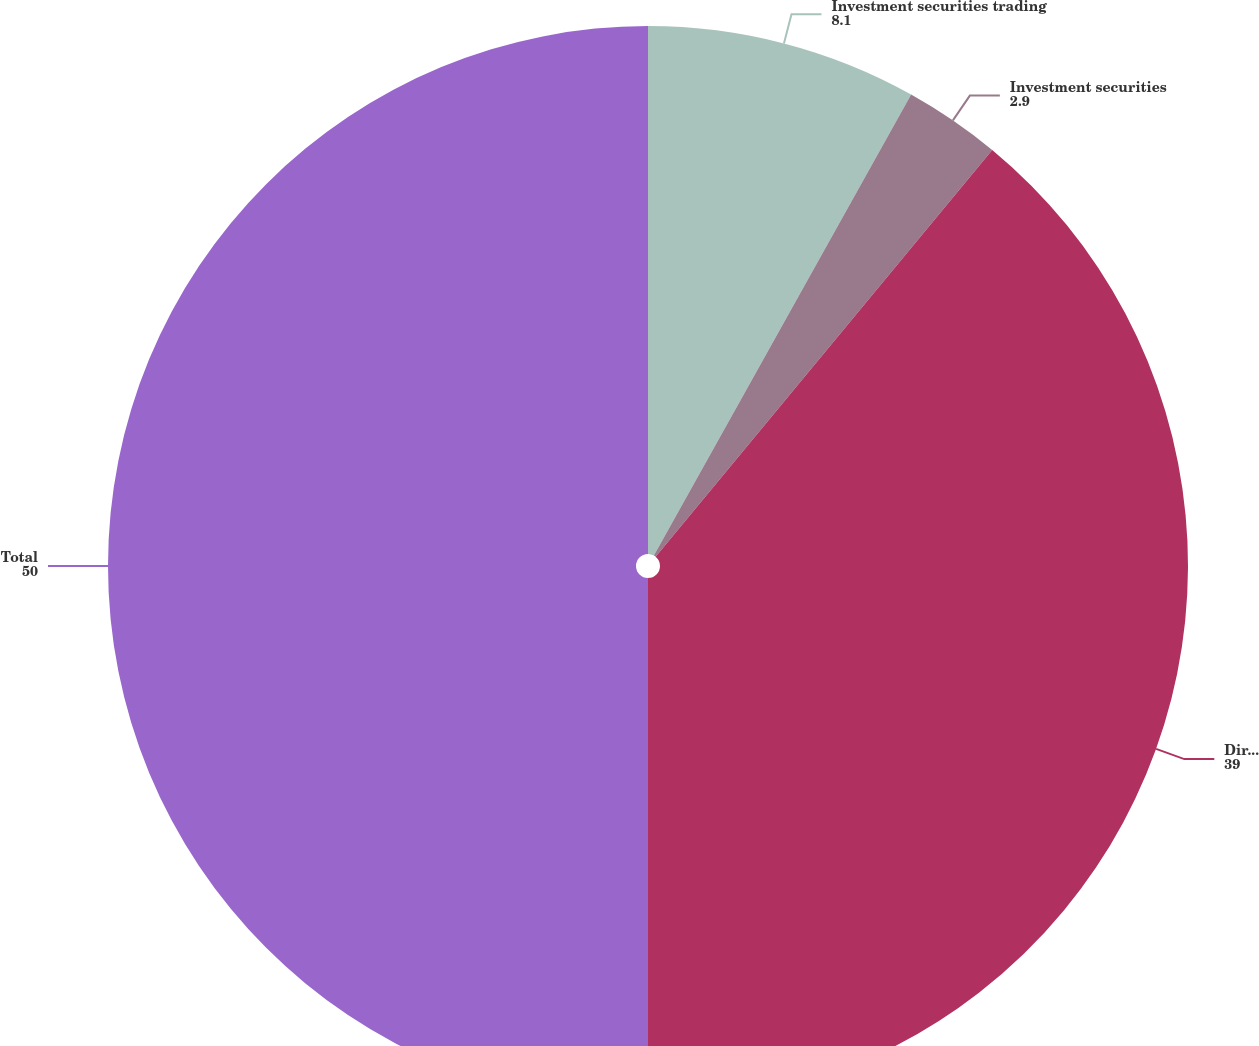Convert chart. <chart><loc_0><loc_0><loc_500><loc_500><pie_chart><fcel>Investment securities trading<fcel>Investment securities<fcel>Direct investments in<fcel>Total<nl><fcel>8.1%<fcel>2.9%<fcel>39.0%<fcel>50.0%<nl></chart> 